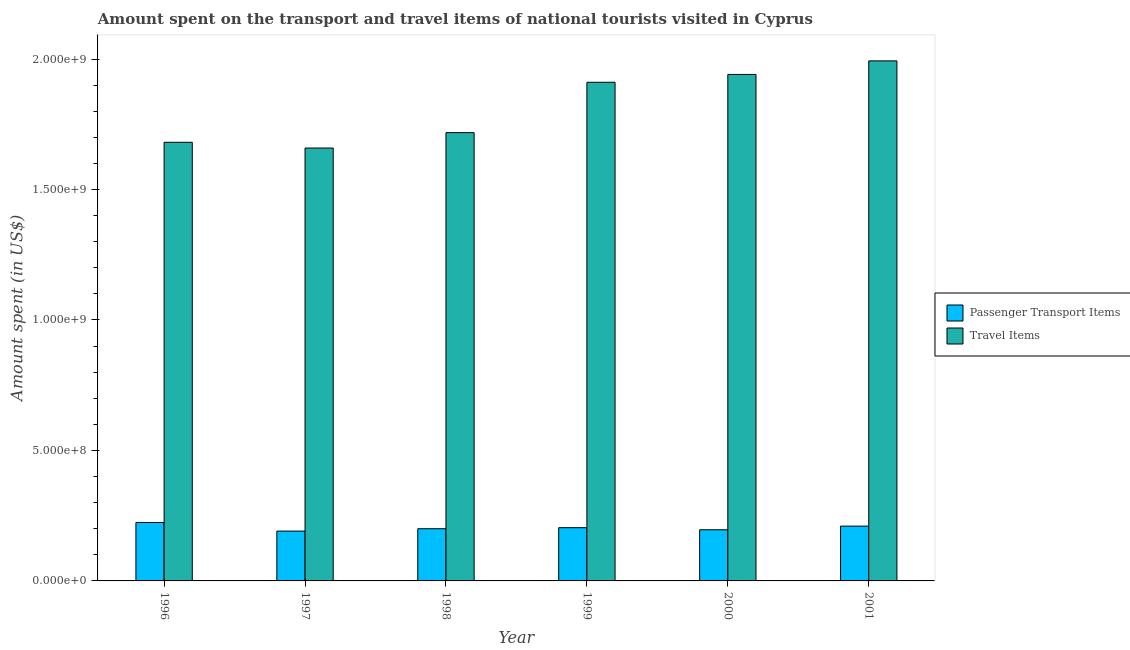How many different coloured bars are there?
Ensure brevity in your answer.  2. How many groups of bars are there?
Provide a succinct answer. 6. Are the number of bars per tick equal to the number of legend labels?
Your response must be concise. Yes. Are the number of bars on each tick of the X-axis equal?
Give a very brief answer. Yes. How many bars are there on the 1st tick from the right?
Your response must be concise. 2. What is the amount spent in travel items in 2000?
Ensure brevity in your answer.  1.94e+09. Across all years, what is the maximum amount spent in travel items?
Ensure brevity in your answer.  1.99e+09. Across all years, what is the minimum amount spent in travel items?
Make the answer very short. 1.66e+09. In which year was the amount spent in travel items maximum?
Your answer should be compact. 2001. What is the total amount spent in travel items in the graph?
Make the answer very short. 1.09e+1. What is the difference between the amount spent on passenger transport items in 1996 and that in 1998?
Ensure brevity in your answer.  2.40e+07. What is the difference between the amount spent on passenger transport items in 2000 and the amount spent in travel items in 1999?
Your response must be concise. -8.00e+06. What is the average amount spent in travel items per year?
Keep it short and to the point. 1.82e+09. In the year 1996, what is the difference between the amount spent on passenger transport items and amount spent in travel items?
Your answer should be very brief. 0. In how many years, is the amount spent on passenger transport items greater than 1000000000 US$?
Your answer should be very brief. 0. What is the ratio of the amount spent in travel items in 1997 to that in 1999?
Give a very brief answer. 0.87. Is the amount spent in travel items in 1997 less than that in 2001?
Provide a short and direct response. Yes. What is the difference between the highest and the second highest amount spent in travel items?
Your answer should be very brief. 5.20e+07. What is the difference between the highest and the lowest amount spent in travel items?
Give a very brief answer. 3.34e+08. In how many years, is the amount spent in travel items greater than the average amount spent in travel items taken over all years?
Provide a short and direct response. 3. What does the 1st bar from the left in 1996 represents?
Your response must be concise. Passenger Transport Items. What does the 1st bar from the right in 1998 represents?
Provide a succinct answer. Travel Items. How many bars are there?
Provide a short and direct response. 12. Are all the bars in the graph horizontal?
Ensure brevity in your answer.  No. Does the graph contain any zero values?
Provide a succinct answer. No. Where does the legend appear in the graph?
Give a very brief answer. Center right. How are the legend labels stacked?
Give a very brief answer. Vertical. What is the title of the graph?
Make the answer very short. Amount spent on the transport and travel items of national tourists visited in Cyprus. Does "Borrowers" appear as one of the legend labels in the graph?
Ensure brevity in your answer.  No. What is the label or title of the X-axis?
Your answer should be very brief. Year. What is the label or title of the Y-axis?
Ensure brevity in your answer.  Amount spent (in US$). What is the Amount spent (in US$) of Passenger Transport Items in 1996?
Offer a terse response. 2.24e+08. What is the Amount spent (in US$) of Travel Items in 1996?
Make the answer very short. 1.68e+09. What is the Amount spent (in US$) in Passenger Transport Items in 1997?
Your answer should be compact. 1.91e+08. What is the Amount spent (in US$) in Travel Items in 1997?
Make the answer very short. 1.66e+09. What is the Amount spent (in US$) of Travel Items in 1998?
Ensure brevity in your answer.  1.72e+09. What is the Amount spent (in US$) in Passenger Transport Items in 1999?
Offer a terse response. 2.04e+08. What is the Amount spent (in US$) in Travel Items in 1999?
Provide a succinct answer. 1.91e+09. What is the Amount spent (in US$) of Passenger Transport Items in 2000?
Provide a short and direct response. 1.96e+08. What is the Amount spent (in US$) in Travel Items in 2000?
Your answer should be very brief. 1.94e+09. What is the Amount spent (in US$) of Passenger Transport Items in 2001?
Give a very brief answer. 2.10e+08. What is the Amount spent (in US$) in Travel Items in 2001?
Provide a succinct answer. 1.99e+09. Across all years, what is the maximum Amount spent (in US$) of Passenger Transport Items?
Offer a terse response. 2.24e+08. Across all years, what is the maximum Amount spent (in US$) of Travel Items?
Your answer should be compact. 1.99e+09. Across all years, what is the minimum Amount spent (in US$) in Passenger Transport Items?
Your answer should be very brief. 1.91e+08. Across all years, what is the minimum Amount spent (in US$) of Travel Items?
Provide a short and direct response. 1.66e+09. What is the total Amount spent (in US$) of Passenger Transport Items in the graph?
Provide a short and direct response. 1.22e+09. What is the total Amount spent (in US$) in Travel Items in the graph?
Make the answer very short. 1.09e+1. What is the difference between the Amount spent (in US$) in Passenger Transport Items in 1996 and that in 1997?
Offer a terse response. 3.30e+07. What is the difference between the Amount spent (in US$) in Travel Items in 1996 and that in 1997?
Offer a very short reply. 2.20e+07. What is the difference between the Amount spent (in US$) of Passenger Transport Items in 1996 and that in 1998?
Provide a succinct answer. 2.40e+07. What is the difference between the Amount spent (in US$) in Travel Items in 1996 and that in 1998?
Ensure brevity in your answer.  -3.70e+07. What is the difference between the Amount spent (in US$) of Travel Items in 1996 and that in 1999?
Ensure brevity in your answer.  -2.30e+08. What is the difference between the Amount spent (in US$) of Passenger Transport Items in 1996 and that in 2000?
Keep it short and to the point. 2.80e+07. What is the difference between the Amount spent (in US$) in Travel Items in 1996 and that in 2000?
Ensure brevity in your answer.  -2.60e+08. What is the difference between the Amount spent (in US$) in Passenger Transport Items in 1996 and that in 2001?
Ensure brevity in your answer.  1.40e+07. What is the difference between the Amount spent (in US$) in Travel Items in 1996 and that in 2001?
Provide a succinct answer. -3.12e+08. What is the difference between the Amount spent (in US$) in Passenger Transport Items in 1997 and that in 1998?
Your answer should be compact. -9.00e+06. What is the difference between the Amount spent (in US$) of Travel Items in 1997 and that in 1998?
Keep it short and to the point. -5.90e+07. What is the difference between the Amount spent (in US$) of Passenger Transport Items in 1997 and that in 1999?
Make the answer very short. -1.30e+07. What is the difference between the Amount spent (in US$) of Travel Items in 1997 and that in 1999?
Ensure brevity in your answer.  -2.52e+08. What is the difference between the Amount spent (in US$) of Passenger Transport Items in 1997 and that in 2000?
Offer a terse response. -5.00e+06. What is the difference between the Amount spent (in US$) of Travel Items in 1997 and that in 2000?
Provide a succinct answer. -2.82e+08. What is the difference between the Amount spent (in US$) of Passenger Transport Items in 1997 and that in 2001?
Offer a terse response. -1.90e+07. What is the difference between the Amount spent (in US$) in Travel Items in 1997 and that in 2001?
Ensure brevity in your answer.  -3.34e+08. What is the difference between the Amount spent (in US$) in Passenger Transport Items in 1998 and that in 1999?
Provide a short and direct response. -4.00e+06. What is the difference between the Amount spent (in US$) of Travel Items in 1998 and that in 1999?
Ensure brevity in your answer.  -1.93e+08. What is the difference between the Amount spent (in US$) of Passenger Transport Items in 1998 and that in 2000?
Provide a short and direct response. 4.00e+06. What is the difference between the Amount spent (in US$) of Travel Items in 1998 and that in 2000?
Offer a very short reply. -2.23e+08. What is the difference between the Amount spent (in US$) in Passenger Transport Items in 1998 and that in 2001?
Make the answer very short. -1.00e+07. What is the difference between the Amount spent (in US$) in Travel Items in 1998 and that in 2001?
Offer a terse response. -2.75e+08. What is the difference between the Amount spent (in US$) of Travel Items in 1999 and that in 2000?
Your answer should be very brief. -3.00e+07. What is the difference between the Amount spent (in US$) in Passenger Transport Items in 1999 and that in 2001?
Provide a short and direct response. -6.00e+06. What is the difference between the Amount spent (in US$) in Travel Items in 1999 and that in 2001?
Offer a very short reply. -8.20e+07. What is the difference between the Amount spent (in US$) in Passenger Transport Items in 2000 and that in 2001?
Give a very brief answer. -1.40e+07. What is the difference between the Amount spent (in US$) of Travel Items in 2000 and that in 2001?
Your answer should be compact. -5.20e+07. What is the difference between the Amount spent (in US$) in Passenger Transport Items in 1996 and the Amount spent (in US$) in Travel Items in 1997?
Offer a terse response. -1.44e+09. What is the difference between the Amount spent (in US$) of Passenger Transport Items in 1996 and the Amount spent (in US$) of Travel Items in 1998?
Make the answer very short. -1.49e+09. What is the difference between the Amount spent (in US$) of Passenger Transport Items in 1996 and the Amount spent (in US$) of Travel Items in 1999?
Ensure brevity in your answer.  -1.69e+09. What is the difference between the Amount spent (in US$) in Passenger Transport Items in 1996 and the Amount spent (in US$) in Travel Items in 2000?
Make the answer very short. -1.72e+09. What is the difference between the Amount spent (in US$) in Passenger Transport Items in 1996 and the Amount spent (in US$) in Travel Items in 2001?
Give a very brief answer. -1.77e+09. What is the difference between the Amount spent (in US$) of Passenger Transport Items in 1997 and the Amount spent (in US$) of Travel Items in 1998?
Offer a terse response. -1.53e+09. What is the difference between the Amount spent (in US$) in Passenger Transport Items in 1997 and the Amount spent (in US$) in Travel Items in 1999?
Keep it short and to the point. -1.72e+09. What is the difference between the Amount spent (in US$) of Passenger Transport Items in 1997 and the Amount spent (in US$) of Travel Items in 2000?
Make the answer very short. -1.75e+09. What is the difference between the Amount spent (in US$) of Passenger Transport Items in 1997 and the Amount spent (in US$) of Travel Items in 2001?
Make the answer very short. -1.80e+09. What is the difference between the Amount spent (in US$) of Passenger Transport Items in 1998 and the Amount spent (in US$) of Travel Items in 1999?
Ensure brevity in your answer.  -1.71e+09. What is the difference between the Amount spent (in US$) in Passenger Transport Items in 1998 and the Amount spent (in US$) in Travel Items in 2000?
Your response must be concise. -1.74e+09. What is the difference between the Amount spent (in US$) in Passenger Transport Items in 1998 and the Amount spent (in US$) in Travel Items in 2001?
Offer a very short reply. -1.79e+09. What is the difference between the Amount spent (in US$) of Passenger Transport Items in 1999 and the Amount spent (in US$) of Travel Items in 2000?
Keep it short and to the point. -1.74e+09. What is the difference between the Amount spent (in US$) of Passenger Transport Items in 1999 and the Amount spent (in US$) of Travel Items in 2001?
Offer a very short reply. -1.79e+09. What is the difference between the Amount spent (in US$) in Passenger Transport Items in 2000 and the Amount spent (in US$) in Travel Items in 2001?
Offer a terse response. -1.80e+09. What is the average Amount spent (in US$) of Passenger Transport Items per year?
Ensure brevity in your answer.  2.04e+08. What is the average Amount spent (in US$) of Travel Items per year?
Keep it short and to the point. 1.82e+09. In the year 1996, what is the difference between the Amount spent (in US$) of Passenger Transport Items and Amount spent (in US$) of Travel Items?
Ensure brevity in your answer.  -1.46e+09. In the year 1997, what is the difference between the Amount spent (in US$) of Passenger Transport Items and Amount spent (in US$) of Travel Items?
Give a very brief answer. -1.47e+09. In the year 1998, what is the difference between the Amount spent (in US$) of Passenger Transport Items and Amount spent (in US$) of Travel Items?
Offer a terse response. -1.52e+09. In the year 1999, what is the difference between the Amount spent (in US$) of Passenger Transport Items and Amount spent (in US$) of Travel Items?
Your answer should be very brief. -1.71e+09. In the year 2000, what is the difference between the Amount spent (in US$) of Passenger Transport Items and Amount spent (in US$) of Travel Items?
Your response must be concise. -1.74e+09. In the year 2001, what is the difference between the Amount spent (in US$) of Passenger Transport Items and Amount spent (in US$) of Travel Items?
Offer a very short reply. -1.78e+09. What is the ratio of the Amount spent (in US$) of Passenger Transport Items in 1996 to that in 1997?
Keep it short and to the point. 1.17. What is the ratio of the Amount spent (in US$) in Travel Items in 1996 to that in 1997?
Your response must be concise. 1.01. What is the ratio of the Amount spent (in US$) in Passenger Transport Items in 1996 to that in 1998?
Ensure brevity in your answer.  1.12. What is the ratio of the Amount spent (in US$) in Travel Items in 1996 to that in 1998?
Give a very brief answer. 0.98. What is the ratio of the Amount spent (in US$) in Passenger Transport Items in 1996 to that in 1999?
Keep it short and to the point. 1.1. What is the ratio of the Amount spent (in US$) in Travel Items in 1996 to that in 1999?
Your response must be concise. 0.88. What is the ratio of the Amount spent (in US$) of Passenger Transport Items in 1996 to that in 2000?
Offer a terse response. 1.14. What is the ratio of the Amount spent (in US$) in Travel Items in 1996 to that in 2000?
Make the answer very short. 0.87. What is the ratio of the Amount spent (in US$) of Passenger Transport Items in 1996 to that in 2001?
Provide a succinct answer. 1.07. What is the ratio of the Amount spent (in US$) in Travel Items in 1996 to that in 2001?
Give a very brief answer. 0.84. What is the ratio of the Amount spent (in US$) in Passenger Transport Items in 1997 to that in 1998?
Keep it short and to the point. 0.95. What is the ratio of the Amount spent (in US$) in Travel Items in 1997 to that in 1998?
Ensure brevity in your answer.  0.97. What is the ratio of the Amount spent (in US$) in Passenger Transport Items in 1997 to that in 1999?
Your answer should be very brief. 0.94. What is the ratio of the Amount spent (in US$) of Travel Items in 1997 to that in 1999?
Your answer should be very brief. 0.87. What is the ratio of the Amount spent (in US$) of Passenger Transport Items in 1997 to that in 2000?
Your answer should be very brief. 0.97. What is the ratio of the Amount spent (in US$) of Travel Items in 1997 to that in 2000?
Provide a succinct answer. 0.85. What is the ratio of the Amount spent (in US$) of Passenger Transport Items in 1997 to that in 2001?
Keep it short and to the point. 0.91. What is the ratio of the Amount spent (in US$) of Travel Items in 1997 to that in 2001?
Your answer should be compact. 0.83. What is the ratio of the Amount spent (in US$) of Passenger Transport Items in 1998 to that in 1999?
Offer a very short reply. 0.98. What is the ratio of the Amount spent (in US$) of Travel Items in 1998 to that in 1999?
Provide a short and direct response. 0.9. What is the ratio of the Amount spent (in US$) of Passenger Transport Items in 1998 to that in 2000?
Your answer should be compact. 1.02. What is the ratio of the Amount spent (in US$) in Travel Items in 1998 to that in 2000?
Provide a short and direct response. 0.89. What is the ratio of the Amount spent (in US$) in Travel Items in 1998 to that in 2001?
Your answer should be very brief. 0.86. What is the ratio of the Amount spent (in US$) in Passenger Transport Items in 1999 to that in 2000?
Ensure brevity in your answer.  1.04. What is the ratio of the Amount spent (in US$) in Travel Items in 1999 to that in 2000?
Keep it short and to the point. 0.98. What is the ratio of the Amount spent (in US$) of Passenger Transport Items in 1999 to that in 2001?
Your response must be concise. 0.97. What is the ratio of the Amount spent (in US$) in Travel Items in 1999 to that in 2001?
Ensure brevity in your answer.  0.96. What is the ratio of the Amount spent (in US$) of Passenger Transport Items in 2000 to that in 2001?
Offer a terse response. 0.93. What is the ratio of the Amount spent (in US$) in Travel Items in 2000 to that in 2001?
Your response must be concise. 0.97. What is the difference between the highest and the second highest Amount spent (in US$) of Passenger Transport Items?
Provide a succinct answer. 1.40e+07. What is the difference between the highest and the second highest Amount spent (in US$) in Travel Items?
Keep it short and to the point. 5.20e+07. What is the difference between the highest and the lowest Amount spent (in US$) of Passenger Transport Items?
Keep it short and to the point. 3.30e+07. What is the difference between the highest and the lowest Amount spent (in US$) of Travel Items?
Keep it short and to the point. 3.34e+08. 